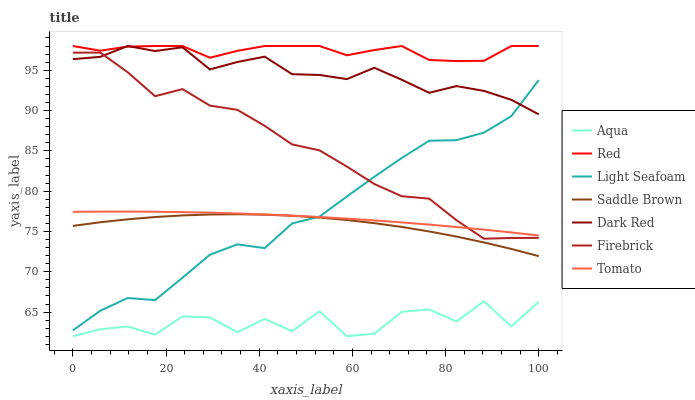Does Aqua have the minimum area under the curve?
Answer yes or no. Yes. Does Red have the maximum area under the curve?
Answer yes or no. Yes. Does Dark Red have the minimum area under the curve?
Answer yes or no. No. Does Dark Red have the maximum area under the curve?
Answer yes or no. No. Is Tomato the smoothest?
Answer yes or no. Yes. Is Aqua the roughest?
Answer yes or no. Yes. Is Dark Red the smoothest?
Answer yes or no. No. Is Dark Red the roughest?
Answer yes or no. No. Does Aqua have the lowest value?
Answer yes or no. Yes. Does Dark Red have the lowest value?
Answer yes or no. No. Does Red have the highest value?
Answer yes or no. Yes. Does Firebrick have the highest value?
Answer yes or no. No. Is Aqua less than Dark Red?
Answer yes or no. Yes. Is Firebrick greater than Aqua?
Answer yes or no. Yes. Does Dark Red intersect Firebrick?
Answer yes or no. Yes. Is Dark Red less than Firebrick?
Answer yes or no. No. Is Dark Red greater than Firebrick?
Answer yes or no. No. Does Aqua intersect Dark Red?
Answer yes or no. No. 